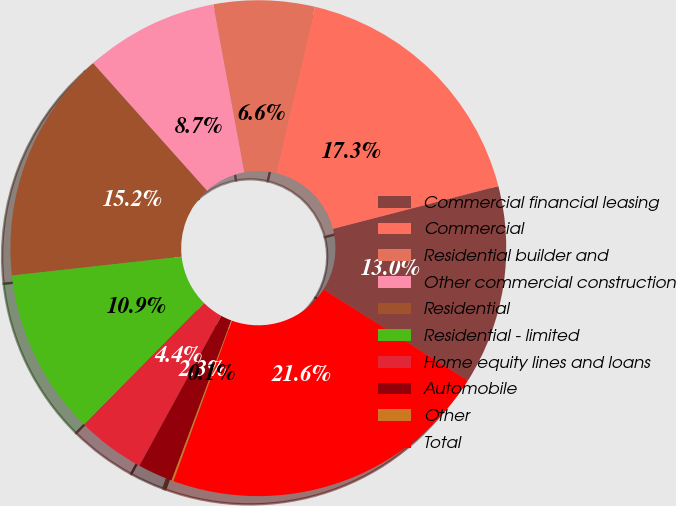Convert chart. <chart><loc_0><loc_0><loc_500><loc_500><pie_chart><fcel>Commercial financial leasing<fcel>Commercial<fcel>Residential builder and<fcel>Other commercial construction<fcel>Residential<fcel>Residential - limited<fcel>Home equity lines and loans<fcel>Automobile<fcel>Other<fcel>Total<nl><fcel>13.0%<fcel>17.3%<fcel>6.57%<fcel>8.71%<fcel>15.15%<fcel>10.86%<fcel>4.42%<fcel>2.27%<fcel>0.13%<fcel>21.59%<nl></chart> 